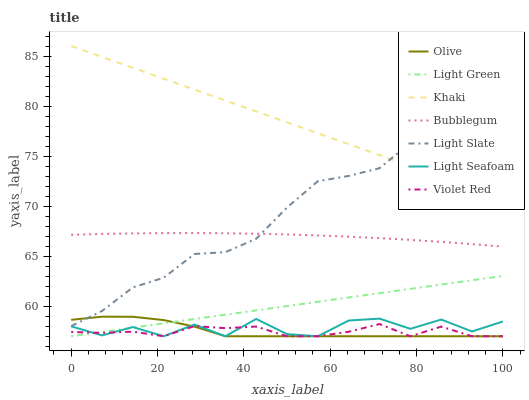Does Violet Red have the minimum area under the curve?
Answer yes or no. Yes. Does Khaki have the maximum area under the curve?
Answer yes or no. Yes. Does Light Slate have the minimum area under the curve?
Answer yes or no. No. Does Light Slate have the maximum area under the curve?
Answer yes or no. No. Is Light Green the smoothest?
Answer yes or no. Yes. Is Light Seafoam the roughest?
Answer yes or no. Yes. Is Khaki the smoothest?
Answer yes or no. No. Is Khaki the roughest?
Answer yes or no. No. Does Violet Red have the lowest value?
Answer yes or no. Yes. Does Light Slate have the lowest value?
Answer yes or no. No. Does Khaki have the highest value?
Answer yes or no. Yes. Does Light Slate have the highest value?
Answer yes or no. No. Is Light Seafoam less than Bubblegum?
Answer yes or no. Yes. Is Light Slate greater than Light Seafoam?
Answer yes or no. Yes. Does Violet Red intersect Olive?
Answer yes or no. Yes. Is Violet Red less than Olive?
Answer yes or no. No. Is Violet Red greater than Olive?
Answer yes or no. No. Does Light Seafoam intersect Bubblegum?
Answer yes or no. No. 